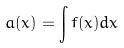<formula> <loc_0><loc_0><loc_500><loc_500>a ( x ) = \int f ( x ) d x</formula> 